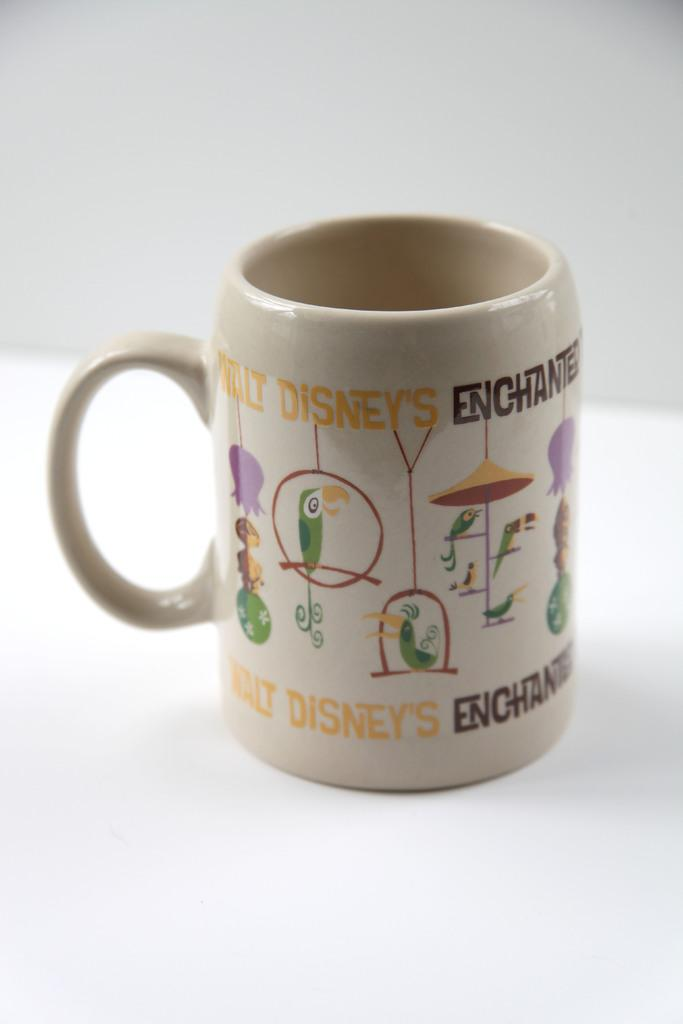<image>
Describe the image concisely. A coffee mug featuring several drawings of parrots with text that reads walt disney on the top and bottom. 